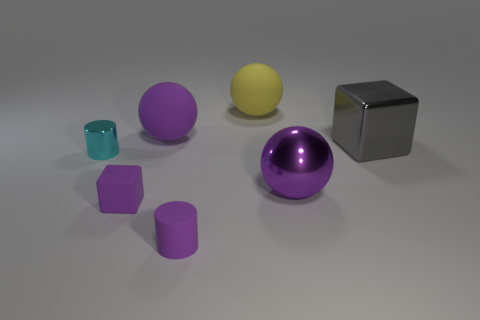There is a metallic thing that is the same color as the tiny cube; what shape is it?
Offer a very short reply. Sphere. There is a purple rubber cylinder; is it the same size as the block that is behind the small cyan cylinder?
Provide a succinct answer. No. What number of cyan things are either small cylinders or metallic blocks?
Provide a short and direct response. 1. What number of big balls are there?
Your response must be concise. 3. How big is the matte thing in front of the purple block?
Give a very brief answer. Small. Is the size of the gray object the same as the yellow sphere?
Offer a very short reply. Yes. What number of things are either yellow blocks or purple rubber things that are behind the gray shiny object?
Provide a short and direct response. 1. What is the large gray thing made of?
Ensure brevity in your answer.  Metal. Is there anything else of the same color as the tiny rubber cylinder?
Offer a terse response. Yes. Is the tiny cyan object the same shape as the gray metallic object?
Your response must be concise. No. 